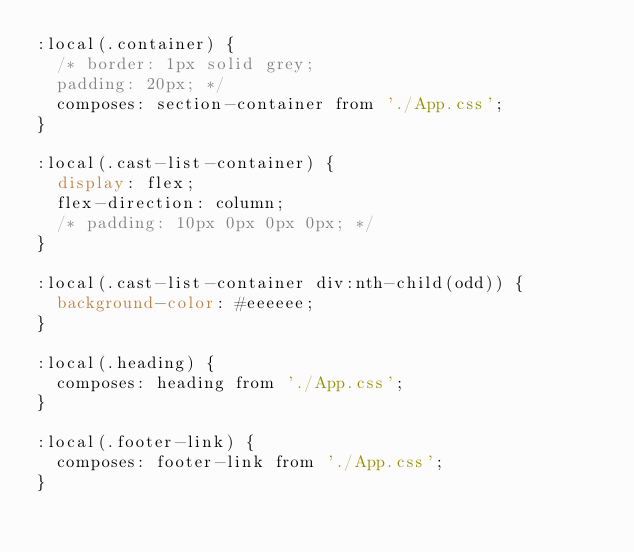<code> <loc_0><loc_0><loc_500><loc_500><_CSS_>:local(.container) {
  /* border: 1px solid grey;
  padding: 20px; */
  composes: section-container from './App.css';
}

:local(.cast-list-container) {
  display: flex;
  flex-direction: column;
  /* padding: 10px 0px 0px 0px; */
}

:local(.cast-list-container div:nth-child(odd)) {
  background-color: #eeeeee;
}

:local(.heading) { 
  composes: heading from './App.css';
}

:local(.footer-link) {
  composes: footer-link from './App.css';
}</code> 